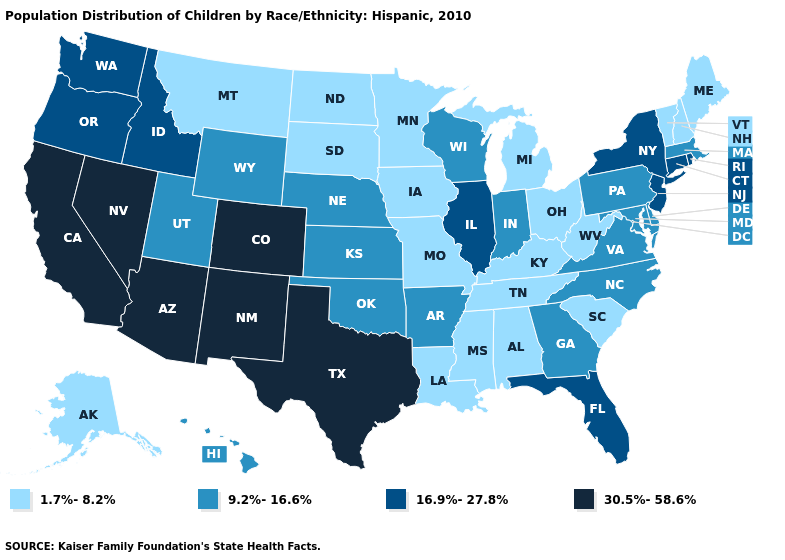What is the value of North Carolina?
Give a very brief answer. 9.2%-16.6%. What is the value of New Mexico?
Keep it brief. 30.5%-58.6%. Name the states that have a value in the range 1.7%-8.2%?
Answer briefly. Alabama, Alaska, Iowa, Kentucky, Louisiana, Maine, Michigan, Minnesota, Mississippi, Missouri, Montana, New Hampshire, North Dakota, Ohio, South Carolina, South Dakota, Tennessee, Vermont, West Virginia. Does the first symbol in the legend represent the smallest category?
Short answer required. Yes. Does Wisconsin have a higher value than Arizona?
Short answer required. No. Name the states that have a value in the range 9.2%-16.6%?
Concise answer only. Arkansas, Delaware, Georgia, Hawaii, Indiana, Kansas, Maryland, Massachusetts, Nebraska, North Carolina, Oklahoma, Pennsylvania, Utah, Virginia, Wisconsin, Wyoming. Among the states that border New Jersey , does Delaware have the lowest value?
Write a very short answer. Yes. What is the lowest value in states that border Colorado?
Be succinct. 9.2%-16.6%. How many symbols are there in the legend?
Concise answer only. 4. Among the states that border Mississippi , does Louisiana have the lowest value?
Quick response, please. Yes. What is the value of Vermont?
Give a very brief answer. 1.7%-8.2%. Name the states that have a value in the range 30.5%-58.6%?
Give a very brief answer. Arizona, California, Colorado, Nevada, New Mexico, Texas. What is the value of West Virginia?
Keep it brief. 1.7%-8.2%. Which states have the lowest value in the USA?
Concise answer only. Alabama, Alaska, Iowa, Kentucky, Louisiana, Maine, Michigan, Minnesota, Mississippi, Missouri, Montana, New Hampshire, North Dakota, Ohio, South Carolina, South Dakota, Tennessee, Vermont, West Virginia. What is the value of Georgia?
Keep it brief. 9.2%-16.6%. 